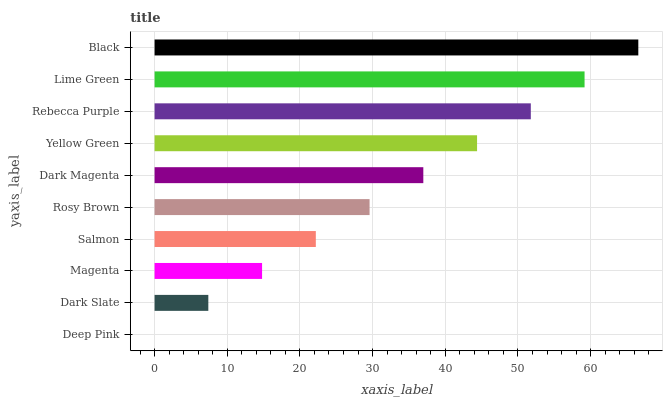Is Deep Pink the minimum?
Answer yes or no. Yes. Is Black the maximum?
Answer yes or no. Yes. Is Dark Slate the minimum?
Answer yes or no. No. Is Dark Slate the maximum?
Answer yes or no. No. Is Dark Slate greater than Deep Pink?
Answer yes or no. Yes. Is Deep Pink less than Dark Slate?
Answer yes or no. Yes. Is Deep Pink greater than Dark Slate?
Answer yes or no. No. Is Dark Slate less than Deep Pink?
Answer yes or no. No. Is Dark Magenta the high median?
Answer yes or no. Yes. Is Rosy Brown the low median?
Answer yes or no. Yes. Is Salmon the high median?
Answer yes or no. No. Is Lime Green the low median?
Answer yes or no. No. 